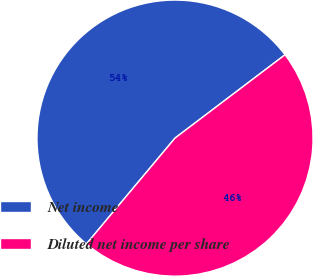Convert chart. <chart><loc_0><loc_0><loc_500><loc_500><pie_chart><fcel>Net income<fcel>Diluted net income per share<nl><fcel>53.59%<fcel>46.41%<nl></chart> 